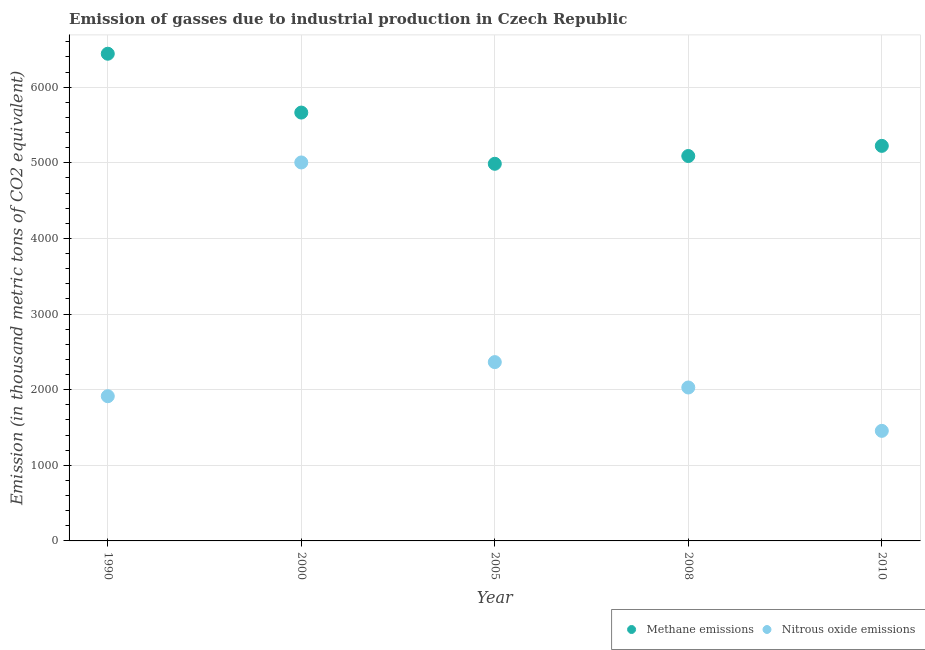What is the amount of methane emissions in 2000?
Your answer should be compact. 5664.2. Across all years, what is the maximum amount of nitrous oxide emissions?
Your answer should be compact. 5004.5. Across all years, what is the minimum amount of methane emissions?
Give a very brief answer. 4986.9. What is the total amount of nitrous oxide emissions in the graph?
Ensure brevity in your answer.  1.28e+04. What is the difference between the amount of methane emissions in 2008 and that in 2010?
Ensure brevity in your answer.  -134.1. What is the difference between the amount of methane emissions in 2000 and the amount of nitrous oxide emissions in 2008?
Your response must be concise. 3635.4. What is the average amount of methane emissions per year?
Ensure brevity in your answer.  5481.36. In the year 2008, what is the difference between the amount of methane emissions and amount of nitrous oxide emissions?
Offer a terse response. 3060.9. In how many years, is the amount of nitrous oxide emissions greater than 3000 thousand metric tons?
Offer a terse response. 1. What is the ratio of the amount of methane emissions in 1990 to that in 2008?
Your answer should be compact. 1.27. Is the amount of nitrous oxide emissions in 2000 less than that in 2008?
Keep it short and to the point. No. Is the difference between the amount of methane emissions in 2005 and 2010 greater than the difference between the amount of nitrous oxide emissions in 2005 and 2010?
Provide a succinct answer. No. What is the difference between the highest and the second highest amount of nitrous oxide emissions?
Give a very brief answer. 2640. What is the difference between the highest and the lowest amount of nitrous oxide emissions?
Provide a short and direct response. 3549.1. Is the sum of the amount of methane emissions in 2005 and 2010 greater than the maximum amount of nitrous oxide emissions across all years?
Offer a terse response. Yes. Does the amount of methane emissions monotonically increase over the years?
Your answer should be very brief. No. How many years are there in the graph?
Give a very brief answer. 5. Does the graph contain grids?
Your answer should be compact. Yes. Where does the legend appear in the graph?
Offer a terse response. Bottom right. What is the title of the graph?
Your answer should be compact. Emission of gasses due to industrial production in Czech Republic. Does "Transport services" appear as one of the legend labels in the graph?
Give a very brief answer. No. What is the label or title of the Y-axis?
Make the answer very short. Emission (in thousand metric tons of CO2 equivalent). What is the Emission (in thousand metric tons of CO2 equivalent) in Methane emissions in 1990?
Your answer should be compact. 6442.2. What is the Emission (in thousand metric tons of CO2 equivalent) in Nitrous oxide emissions in 1990?
Provide a succinct answer. 1913.6. What is the Emission (in thousand metric tons of CO2 equivalent) of Methane emissions in 2000?
Keep it short and to the point. 5664.2. What is the Emission (in thousand metric tons of CO2 equivalent) of Nitrous oxide emissions in 2000?
Your answer should be very brief. 5004.5. What is the Emission (in thousand metric tons of CO2 equivalent) in Methane emissions in 2005?
Your response must be concise. 4986.9. What is the Emission (in thousand metric tons of CO2 equivalent) in Nitrous oxide emissions in 2005?
Give a very brief answer. 2364.5. What is the Emission (in thousand metric tons of CO2 equivalent) in Methane emissions in 2008?
Offer a terse response. 5089.7. What is the Emission (in thousand metric tons of CO2 equivalent) in Nitrous oxide emissions in 2008?
Offer a very short reply. 2028.8. What is the Emission (in thousand metric tons of CO2 equivalent) in Methane emissions in 2010?
Provide a short and direct response. 5223.8. What is the Emission (in thousand metric tons of CO2 equivalent) of Nitrous oxide emissions in 2010?
Keep it short and to the point. 1455.4. Across all years, what is the maximum Emission (in thousand metric tons of CO2 equivalent) of Methane emissions?
Offer a very short reply. 6442.2. Across all years, what is the maximum Emission (in thousand metric tons of CO2 equivalent) of Nitrous oxide emissions?
Keep it short and to the point. 5004.5. Across all years, what is the minimum Emission (in thousand metric tons of CO2 equivalent) in Methane emissions?
Make the answer very short. 4986.9. Across all years, what is the minimum Emission (in thousand metric tons of CO2 equivalent) in Nitrous oxide emissions?
Offer a terse response. 1455.4. What is the total Emission (in thousand metric tons of CO2 equivalent) in Methane emissions in the graph?
Ensure brevity in your answer.  2.74e+04. What is the total Emission (in thousand metric tons of CO2 equivalent) of Nitrous oxide emissions in the graph?
Provide a short and direct response. 1.28e+04. What is the difference between the Emission (in thousand metric tons of CO2 equivalent) in Methane emissions in 1990 and that in 2000?
Provide a succinct answer. 778. What is the difference between the Emission (in thousand metric tons of CO2 equivalent) in Nitrous oxide emissions in 1990 and that in 2000?
Provide a short and direct response. -3090.9. What is the difference between the Emission (in thousand metric tons of CO2 equivalent) in Methane emissions in 1990 and that in 2005?
Your answer should be compact. 1455.3. What is the difference between the Emission (in thousand metric tons of CO2 equivalent) of Nitrous oxide emissions in 1990 and that in 2005?
Offer a terse response. -450.9. What is the difference between the Emission (in thousand metric tons of CO2 equivalent) of Methane emissions in 1990 and that in 2008?
Ensure brevity in your answer.  1352.5. What is the difference between the Emission (in thousand metric tons of CO2 equivalent) in Nitrous oxide emissions in 1990 and that in 2008?
Your answer should be very brief. -115.2. What is the difference between the Emission (in thousand metric tons of CO2 equivalent) of Methane emissions in 1990 and that in 2010?
Provide a succinct answer. 1218.4. What is the difference between the Emission (in thousand metric tons of CO2 equivalent) of Nitrous oxide emissions in 1990 and that in 2010?
Your answer should be very brief. 458.2. What is the difference between the Emission (in thousand metric tons of CO2 equivalent) of Methane emissions in 2000 and that in 2005?
Provide a succinct answer. 677.3. What is the difference between the Emission (in thousand metric tons of CO2 equivalent) of Nitrous oxide emissions in 2000 and that in 2005?
Offer a very short reply. 2640. What is the difference between the Emission (in thousand metric tons of CO2 equivalent) in Methane emissions in 2000 and that in 2008?
Offer a terse response. 574.5. What is the difference between the Emission (in thousand metric tons of CO2 equivalent) in Nitrous oxide emissions in 2000 and that in 2008?
Your response must be concise. 2975.7. What is the difference between the Emission (in thousand metric tons of CO2 equivalent) of Methane emissions in 2000 and that in 2010?
Your response must be concise. 440.4. What is the difference between the Emission (in thousand metric tons of CO2 equivalent) in Nitrous oxide emissions in 2000 and that in 2010?
Offer a very short reply. 3549.1. What is the difference between the Emission (in thousand metric tons of CO2 equivalent) of Methane emissions in 2005 and that in 2008?
Your answer should be compact. -102.8. What is the difference between the Emission (in thousand metric tons of CO2 equivalent) of Nitrous oxide emissions in 2005 and that in 2008?
Your answer should be compact. 335.7. What is the difference between the Emission (in thousand metric tons of CO2 equivalent) of Methane emissions in 2005 and that in 2010?
Keep it short and to the point. -236.9. What is the difference between the Emission (in thousand metric tons of CO2 equivalent) of Nitrous oxide emissions in 2005 and that in 2010?
Your response must be concise. 909.1. What is the difference between the Emission (in thousand metric tons of CO2 equivalent) of Methane emissions in 2008 and that in 2010?
Make the answer very short. -134.1. What is the difference between the Emission (in thousand metric tons of CO2 equivalent) in Nitrous oxide emissions in 2008 and that in 2010?
Ensure brevity in your answer.  573.4. What is the difference between the Emission (in thousand metric tons of CO2 equivalent) of Methane emissions in 1990 and the Emission (in thousand metric tons of CO2 equivalent) of Nitrous oxide emissions in 2000?
Offer a terse response. 1437.7. What is the difference between the Emission (in thousand metric tons of CO2 equivalent) of Methane emissions in 1990 and the Emission (in thousand metric tons of CO2 equivalent) of Nitrous oxide emissions in 2005?
Keep it short and to the point. 4077.7. What is the difference between the Emission (in thousand metric tons of CO2 equivalent) in Methane emissions in 1990 and the Emission (in thousand metric tons of CO2 equivalent) in Nitrous oxide emissions in 2008?
Offer a very short reply. 4413.4. What is the difference between the Emission (in thousand metric tons of CO2 equivalent) of Methane emissions in 1990 and the Emission (in thousand metric tons of CO2 equivalent) of Nitrous oxide emissions in 2010?
Ensure brevity in your answer.  4986.8. What is the difference between the Emission (in thousand metric tons of CO2 equivalent) in Methane emissions in 2000 and the Emission (in thousand metric tons of CO2 equivalent) in Nitrous oxide emissions in 2005?
Your response must be concise. 3299.7. What is the difference between the Emission (in thousand metric tons of CO2 equivalent) of Methane emissions in 2000 and the Emission (in thousand metric tons of CO2 equivalent) of Nitrous oxide emissions in 2008?
Keep it short and to the point. 3635.4. What is the difference between the Emission (in thousand metric tons of CO2 equivalent) of Methane emissions in 2000 and the Emission (in thousand metric tons of CO2 equivalent) of Nitrous oxide emissions in 2010?
Your response must be concise. 4208.8. What is the difference between the Emission (in thousand metric tons of CO2 equivalent) of Methane emissions in 2005 and the Emission (in thousand metric tons of CO2 equivalent) of Nitrous oxide emissions in 2008?
Your answer should be very brief. 2958.1. What is the difference between the Emission (in thousand metric tons of CO2 equivalent) of Methane emissions in 2005 and the Emission (in thousand metric tons of CO2 equivalent) of Nitrous oxide emissions in 2010?
Your answer should be very brief. 3531.5. What is the difference between the Emission (in thousand metric tons of CO2 equivalent) of Methane emissions in 2008 and the Emission (in thousand metric tons of CO2 equivalent) of Nitrous oxide emissions in 2010?
Keep it short and to the point. 3634.3. What is the average Emission (in thousand metric tons of CO2 equivalent) of Methane emissions per year?
Make the answer very short. 5481.36. What is the average Emission (in thousand metric tons of CO2 equivalent) of Nitrous oxide emissions per year?
Keep it short and to the point. 2553.36. In the year 1990, what is the difference between the Emission (in thousand metric tons of CO2 equivalent) in Methane emissions and Emission (in thousand metric tons of CO2 equivalent) in Nitrous oxide emissions?
Keep it short and to the point. 4528.6. In the year 2000, what is the difference between the Emission (in thousand metric tons of CO2 equivalent) in Methane emissions and Emission (in thousand metric tons of CO2 equivalent) in Nitrous oxide emissions?
Provide a succinct answer. 659.7. In the year 2005, what is the difference between the Emission (in thousand metric tons of CO2 equivalent) in Methane emissions and Emission (in thousand metric tons of CO2 equivalent) in Nitrous oxide emissions?
Your response must be concise. 2622.4. In the year 2008, what is the difference between the Emission (in thousand metric tons of CO2 equivalent) of Methane emissions and Emission (in thousand metric tons of CO2 equivalent) of Nitrous oxide emissions?
Keep it short and to the point. 3060.9. In the year 2010, what is the difference between the Emission (in thousand metric tons of CO2 equivalent) in Methane emissions and Emission (in thousand metric tons of CO2 equivalent) in Nitrous oxide emissions?
Keep it short and to the point. 3768.4. What is the ratio of the Emission (in thousand metric tons of CO2 equivalent) in Methane emissions in 1990 to that in 2000?
Keep it short and to the point. 1.14. What is the ratio of the Emission (in thousand metric tons of CO2 equivalent) in Nitrous oxide emissions in 1990 to that in 2000?
Your answer should be very brief. 0.38. What is the ratio of the Emission (in thousand metric tons of CO2 equivalent) of Methane emissions in 1990 to that in 2005?
Ensure brevity in your answer.  1.29. What is the ratio of the Emission (in thousand metric tons of CO2 equivalent) in Nitrous oxide emissions in 1990 to that in 2005?
Ensure brevity in your answer.  0.81. What is the ratio of the Emission (in thousand metric tons of CO2 equivalent) in Methane emissions in 1990 to that in 2008?
Offer a very short reply. 1.27. What is the ratio of the Emission (in thousand metric tons of CO2 equivalent) in Nitrous oxide emissions in 1990 to that in 2008?
Provide a succinct answer. 0.94. What is the ratio of the Emission (in thousand metric tons of CO2 equivalent) of Methane emissions in 1990 to that in 2010?
Provide a short and direct response. 1.23. What is the ratio of the Emission (in thousand metric tons of CO2 equivalent) in Nitrous oxide emissions in 1990 to that in 2010?
Ensure brevity in your answer.  1.31. What is the ratio of the Emission (in thousand metric tons of CO2 equivalent) of Methane emissions in 2000 to that in 2005?
Your response must be concise. 1.14. What is the ratio of the Emission (in thousand metric tons of CO2 equivalent) of Nitrous oxide emissions in 2000 to that in 2005?
Make the answer very short. 2.12. What is the ratio of the Emission (in thousand metric tons of CO2 equivalent) in Methane emissions in 2000 to that in 2008?
Ensure brevity in your answer.  1.11. What is the ratio of the Emission (in thousand metric tons of CO2 equivalent) in Nitrous oxide emissions in 2000 to that in 2008?
Your response must be concise. 2.47. What is the ratio of the Emission (in thousand metric tons of CO2 equivalent) of Methane emissions in 2000 to that in 2010?
Your answer should be compact. 1.08. What is the ratio of the Emission (in thousand metric tons of CO2 equivalent) of Nitrous oxide emissions in 2000 to that in 2010?
Ensure brevity in your answer.  3.44. What is the ratio of the Emission (in thousand metric tons of CO2 equivalent) of Methane emissions in 2005 to that in 2008?
Give a very brief answer. 0.98. What is the ratio of the Emission (in thousand metric tons of CO2 equivalent) in Nitrous oxide emissions in 2005 to that in 2008?
Your answer should be compact. 1.17. What is the ratio of the Emission (in thousand metric tons of CO2 equivalent) of Methane emissions in 2005 to that in 2010?
Offer a terse response. 0.95. What is the ratio of the Emission (in thousand metric tons of CO2 equivalent) of Nitrous oxide emissions in 2005 to that in 2010?
Offer a very short reply. 1.62. What is the ratio of the Emission (in thousand metric tons of CO2 equivalent) in Methane emissions in 2008 to that in 2010?
Keep it short and to the point. 0.97. What is the ratio of the Emission (in thousand metric tons of CO2 equivalent) of Nitrous oxide emissions in 2008 to that in 2010?
Keep it short and to the point. 1.39. What is the difference between the highest and the second highest Emission (in thousand metric tons of CO2 equivalent) in Methane emissions?
Provide a short and direct response. 778. What is the difference between the highest and the second highest Emission (in thousand metric tons of CO2 equivalent) in Nitrous oxide emissions?
Make the answer very short. 2640. What is the difference between the highest and the lowest Emission (in thousand metric tons of CO2 equivalent) in Methane emissions?
Ensure brevity in your answer.  1455.3. What is the difference between the highest and the lowest Emission (in thousand metric tons of CO2 equivalent) of Nitrous oxide emissions?
Your response must be concise. 3549.1. 